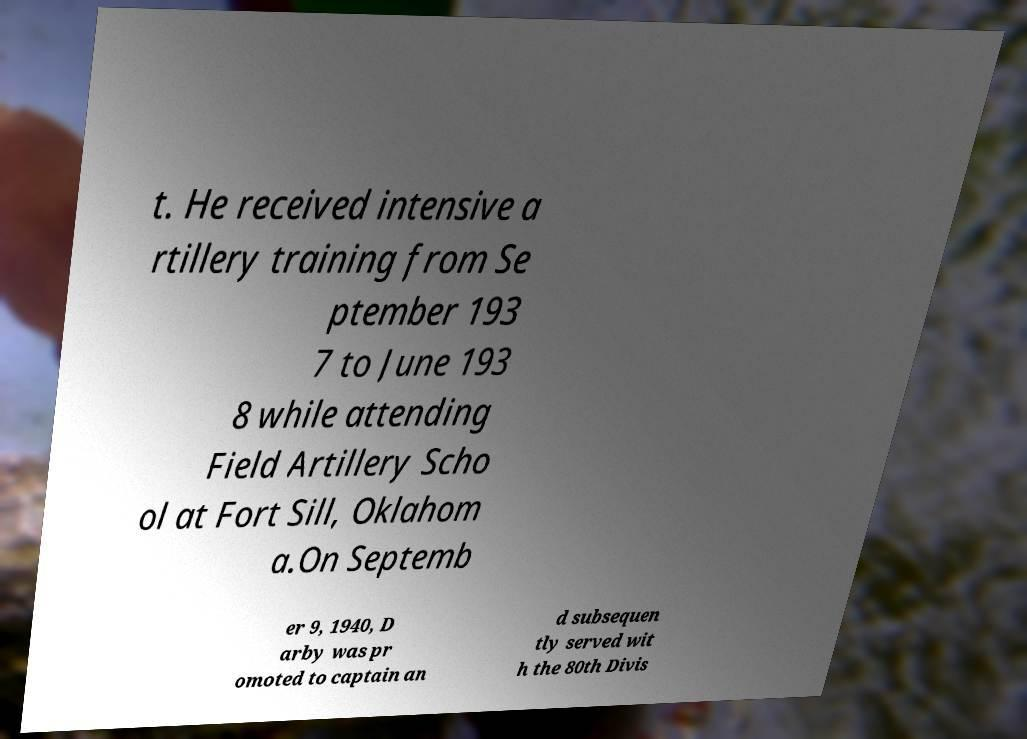What messages or text are displayed in this image? I need them in a readable, typed format. t. He received intensive a rtillery training from Se ptember 193 7 to June 193 8 while attending Field Artillery Scho ol at Fort Sill, Oklahom a.On Septemb er 9, 1940, D arby was pr omoted to captain an d subsequen tly served wit h the 80th Divis 